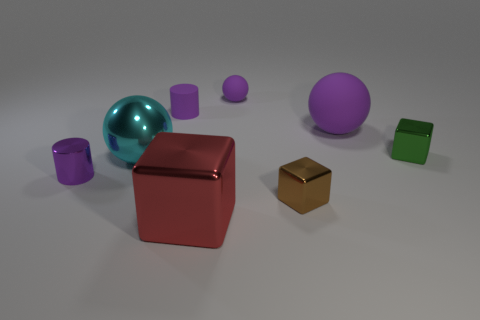Do the tiny purple object that is in front of the green shiny object and the large red metallic object have the same shape?
Give a very brief answer. No. How many small things are purple metallic things or gray rubber cylinders?
Offer a very short reply. 1. Are there an equal number of small metallic cylinders that are on the right side of the tiny green metallic block and green objects in front of the cyan object?
Your response must be concise. Yes. What number of other things are there of the same color as the shiny cylinder?
Keep it short and to the point. 3. Does the large rubber object have the same color as the sphere that is in front of the tiny green shiny object?
Give a very brief answer. No. How many gray things are either small matte objects or balls?
Your response must be concise. 0. Are there the same number of tiny green metallic things that are behind the big matte ball and big rubber spheres?
Offer a terse response. No. Are there any other things that are the same size as the cyan metallic sphere?
Your answer should be compact. Yes. What color is the other large object that is the same shape as the big cyan object?
Provide a succinct answer. Purple. How many other big red metallic things have the same shape as the big red metal object?
Give a very brief answer. 0. 